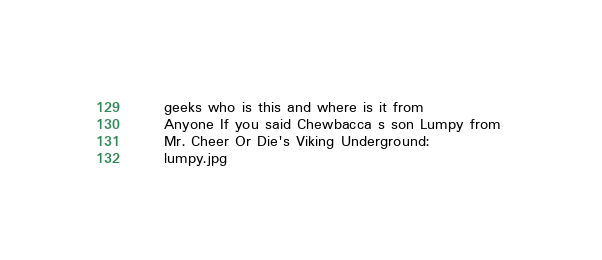Convert code to text. <code><loc_0><loc_0><loc_500><loc_500><_XML_>	 geeks who is this and where is it from 
	 Anyone If you said Chewbacca s son Lumpy from 
	 Mr. Cheer Or Die's Viking Underground: 
	 lumpy.jpg 
</code> 